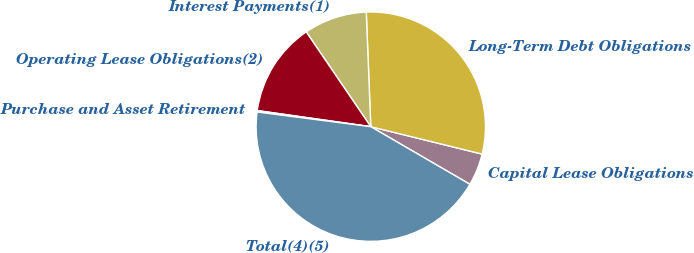Convert chart to OTSL. <chart><loc_0><loc_0><loc_500><loc_500><pie_chart><fcel>Capital Lease Obligations<fcel>Long-Term Debt Obligations<fcel>Interest Payments(1)<fcel>Operating Lease Obligations(2)<fcel>Purchase and Asset Retirement<fcel>Total(4)(5)<nl><fcel>4.54%<fcel>29.47%<fcel>8.89%<fcel>13.24%<fcel>0.2%<fcel>43.66%<nl></chart> 